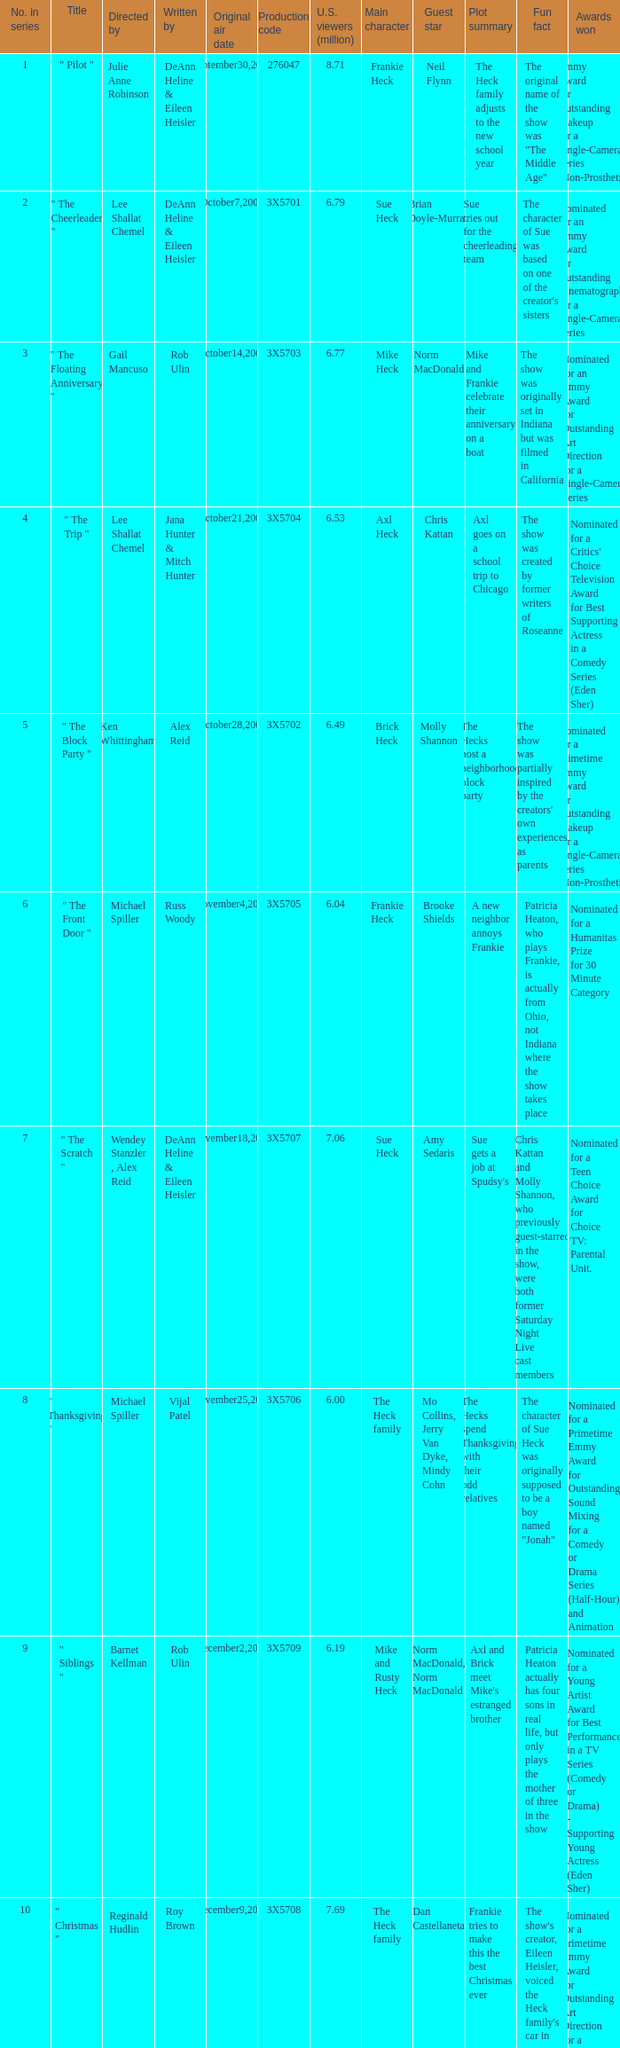How many million U.S. viewers saw the episode with production code 3X5710? 7.55. 